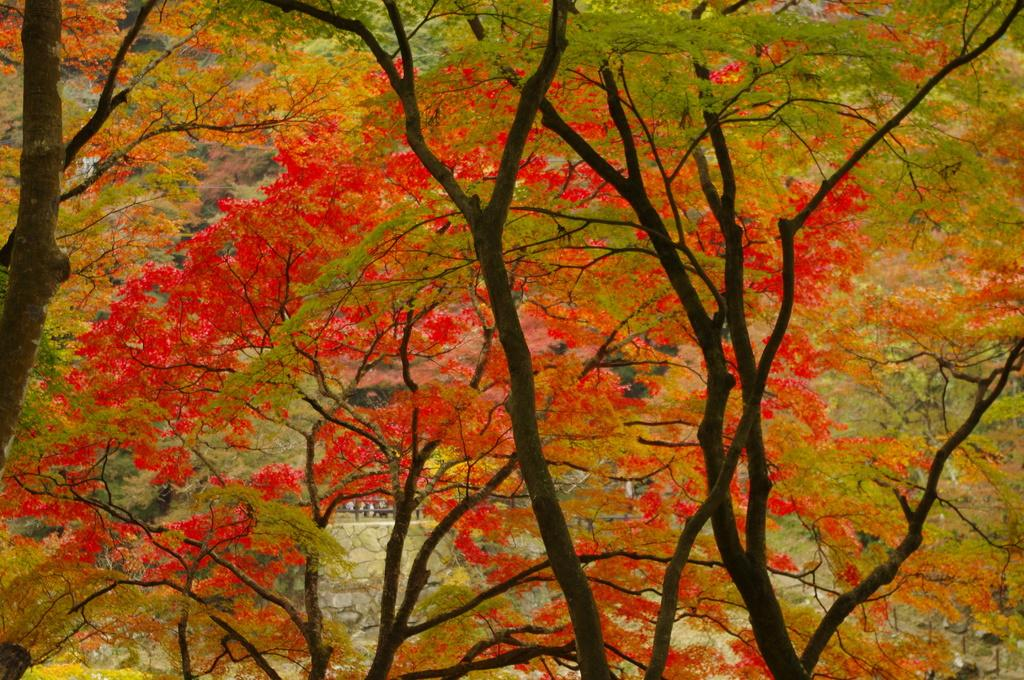What is the primary feature of the image? There are many trees in the image. What can be observed about the trees in the image? There are colorful leaves in the image. What colors are the colorful leaves in the image? The colorful leaves are in red and green colors. What type of stick can be seen holding the colorful leaves in the image? There is no stick present in the image; the colorful leaves are on the trees. What punishment is being given to the trees in the image? There is no punishment being given to the trees in the image; they are simply displaying their natural colorful leaves. 